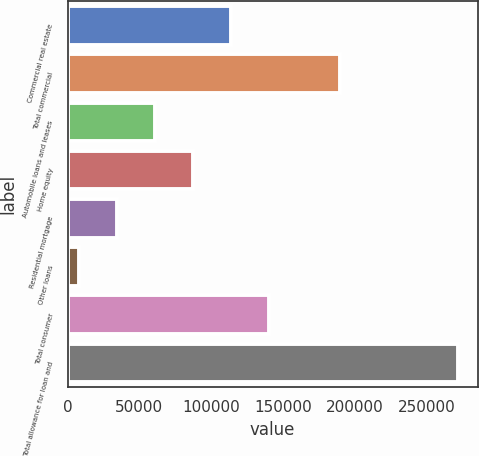Convert chart. <chart><loc_0><loc_0><loc_500><loc_500><bar_chart><fcel>Commercial real estate<fcel>Total commercial<fcel>Automobile loans and leases<fcel>Home equity<fcel>Residential mortgage<fcel>Other loans<fcel>Total consumer<fcel>Total allowance for loan and<nl><fcel>113624<fcel>189753<fcel>60808.8<fcel>87216.2<fcel>34401.4<fcel>7994<fcel>140031<fcel>272068<nl></chart> 